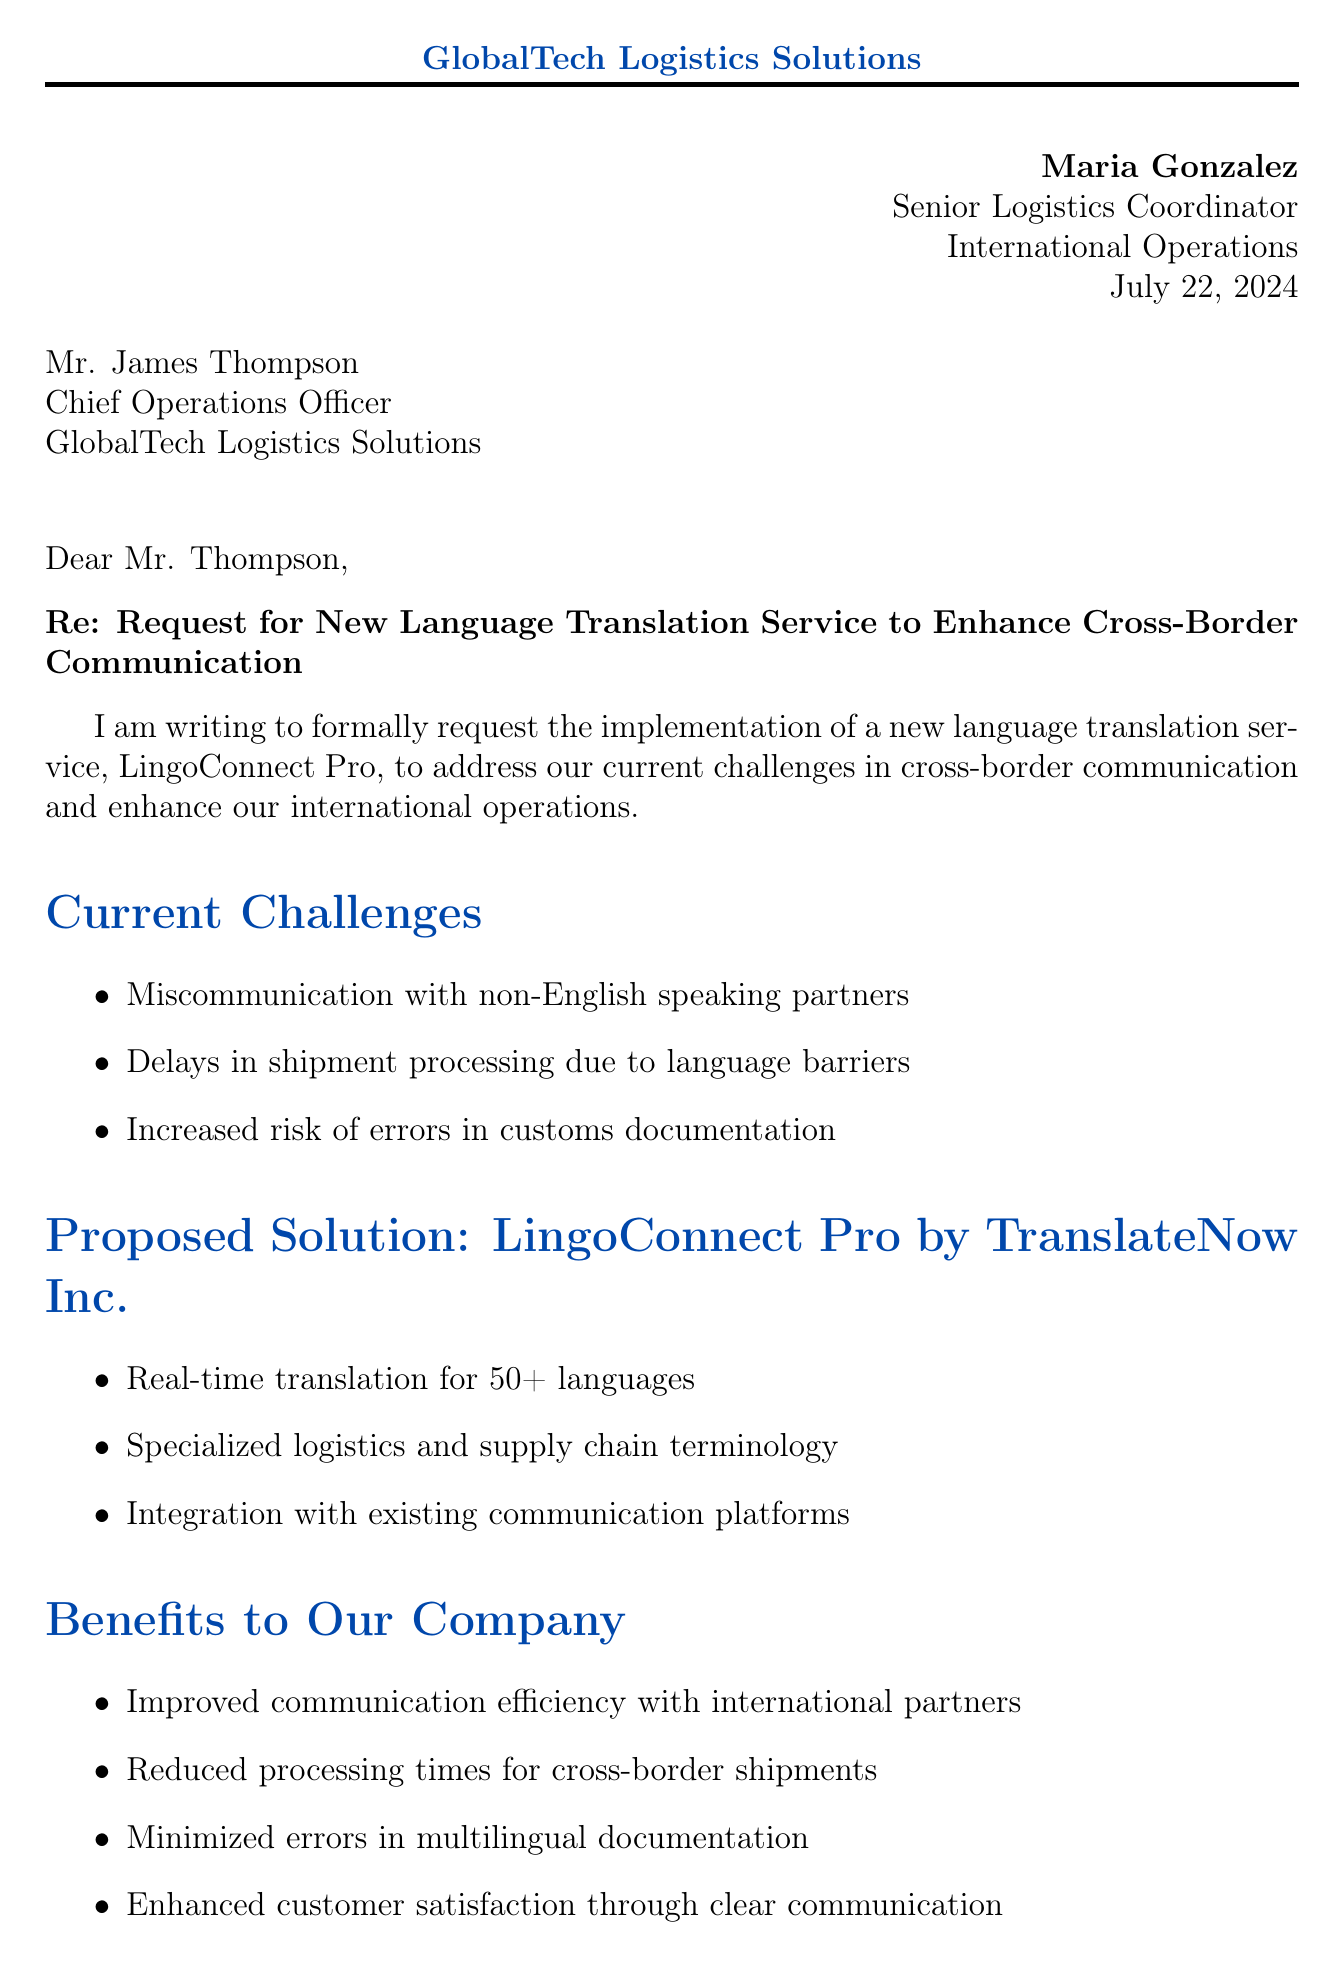what is the name of the language translation service proposed? The letter proposes the implementation of a service called LingoConnect Pro.
Answer: LingoConnect Pro who is the sender of the letter? The sender of the letter is Maria Gonzalez, who is a Senior Logistics Coordinator.
Answer: Maria Gonzalez what are the current challenges mentioned in the letter? The letter outlines challenges such as miscommunication, delays, and increased risk of errors.
Answer: Miscommunication with non-English speaking partners what is the initial investment for the proposed service? The letter specifies the initial investment cost for LingoConnect Pro as part of the cost analysis.
Answer: $15,000 how many languages does LingoConnect Pro support? The letter states that LingoConnect Pro provides real-time translation for over 50 languages.
Answer: 50+ what is the estimated annual savings from implementing the new service? The letter mentions the expected savings derived from operational costs following the service's implementation.
Answer: $50,000 what percentage of shipments are currently delayed due to language-related issues? The supporting data in the letter indicates that a specific percentage of shipments are delayed.
Answer: 25% what is the proposed duration for the trial period with international partners? The implementation plan section details the initial testing phase.
Answer: Two-week what does the sender hope to achieve with this proposal? The sender expresses a desired outcome in the conclusion of the letter regarding operations.
Answer: Streamlined cross-border operations 